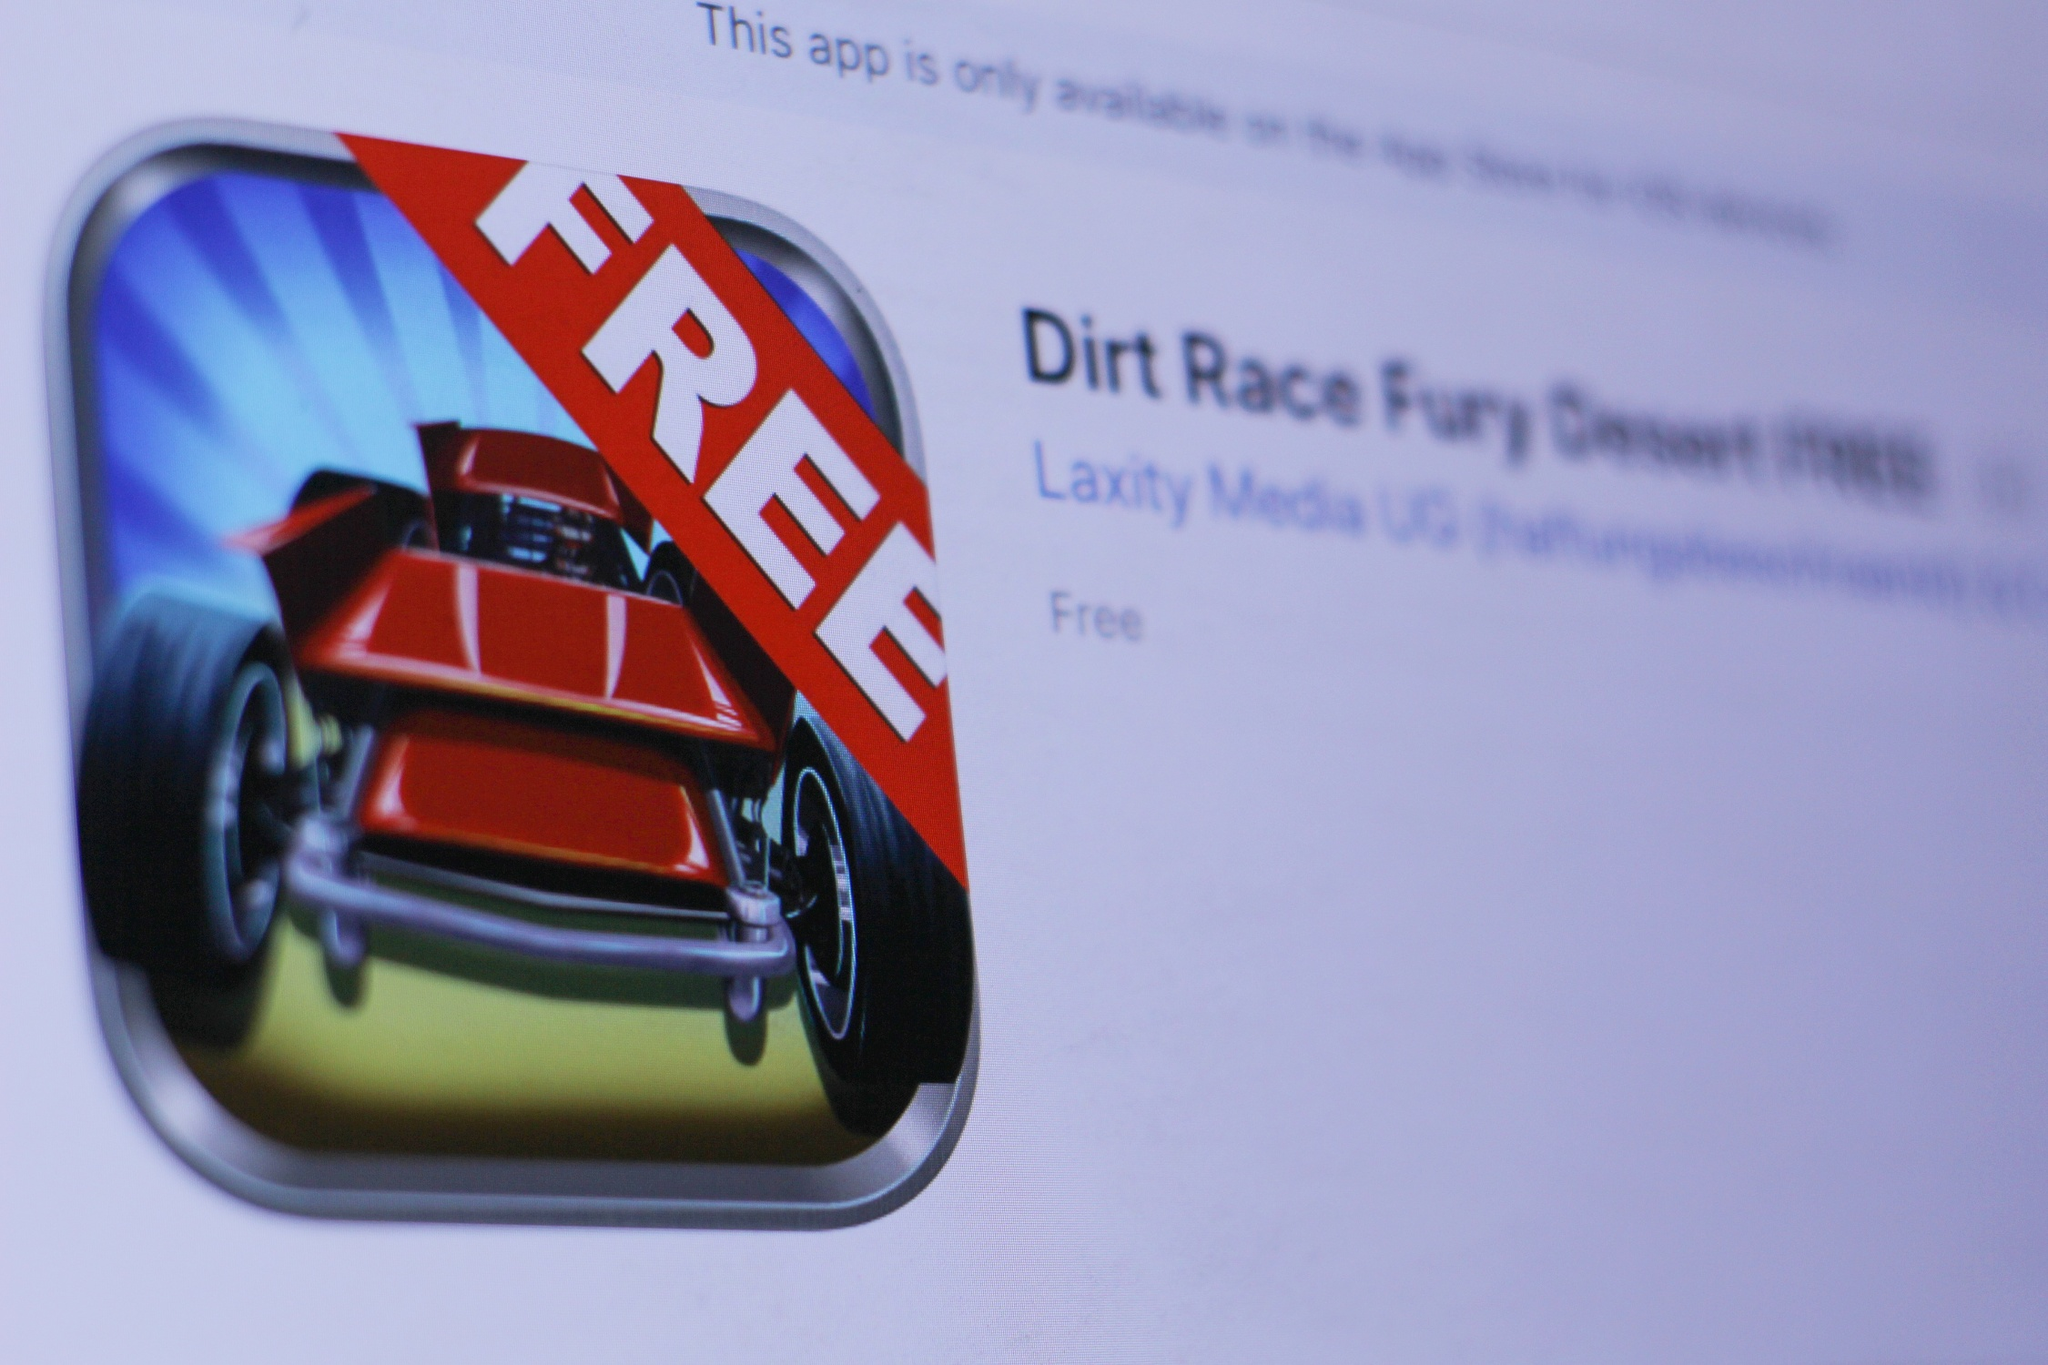What does the 'FREE' label on the app's icon imply about the app's monetization strategy? The 'FREE' label on the app's icon indicates that the application 'Dirt Race Fury Desert FREE' is available for download without any initial cost. This suggests that the developer, Laxity Media UG, likely adopts a freemium monetization strategy. Users can download and play the base game for free, but they might encounter in-app purchases or advertisements. These could include buying virtual currency, unlocking additional maps, vehicles, or premium features, and possibly ad removals to enhance the gaming experience. This strategy widens the potential user base by lowering the entry barrier while still providing opportunities to generate revenue. What technological considerations might be involved in keeping an app like this running smoothly? Maintaining an app like 'Dirt Race Fury Desert FREE' requires various technological considerations to ensure smooth operation and user satisfaction. Firstly, robust backend support is essential for handling user data, leaderboards, and in-app purchases. The app should have an efficient and responsive UI/UX design to provide seamless navigation and gameplay experience. Regular updates to the app will manage bugs, compatibility with new iOS versions, and introduce new features to keep the game engaging.

On the game development side, optimizing the graphics and performance for different iOS devices ensures that the app runs smoothly across a wide range of hardware specifications. The developers must also consider network stability, especially if the game includes any online multiplayer components or live events. Data encryption and secure communication channels are critical for protecting user data, particularly in transactions and personal information. Finally, an analytics framework to monitor user behavior and feedback can guide future improvements and help in making informed enhancements to the app’s functionality and content. Let’s say the app has a hidden treasure feature. How would players find it? In 'Dirt Race Fury Desert FREE', the hidden treasure feature could be an exciting addition that adds depth to the gameplay. Imagine players racing through visually stunning desert tracks, all while keeping an eye out for subtle clues and secret pathways that lead to special hidden treasures. These treasures might include rare car parts, exclusive skins, extra in-game currency, or even hidden levels that offer unique racing experiences.

To find these treasures, players would need to explore beyond the obvious tracks, perhaps venturing into less-trodden areas of the desert. They might encounter cryptic symbols or messages on ancient ruins scattered along the racing path, prompting them to decode these hints to unravel the treasure's location. The app could encourage players to participate in special time-limited events where the likelihood of encountering clues and treasures is higher. This feature not only enhances the sense of adventure but also promotes exploration and rewards curiosity, making the racing experience even more immersive and engaging. Imagine the app becomes a groundbreaking AR (augmented reality) game. What features would it have? If 'Dirt Race Fury Desert FREE' evolved into a groundbreaking AR game, it would revolutionize the gameplay experience by merging digital animations with the real world. Players would use their mobile devices to see virtual race tracks superimposed onto their surroundings, transforming everyday environments into thrilling racecourses. Here are some standout features it could have:

1. **Real-world Tracks:** Players could race through familiar locations like their neighborhood, parks, or city streets, converted into high-octane tracks filled with twists, turns, and jumps.

2. **Interactive Obstacles and Power-ups:** Virtual elements such as ramps, hoops, and barriers appear in the real world, requiring players to physically navigate around them, enhancing the sense of immersion.

3. **Multiplayer Mode:** Friends can join in, racing against each other in real-time, with their devices displaying their competitors’ cars as if they were actually present.

4. **Treasure Hunts:** Like hidden treasures, special AR hotspots can appear in various locations, urging players to explore and reach these points to unlock rewards and bonuses.

5. **Dynamic Weather and Terrain Effects:** Weather effects like rain, dust storms, and fog could dynamically affect the racing experience, making each race unique and challenging.

6. **Customizable AR Cars:** Players could customize their cars with AR skins that appear hyper-realistic, allowing for personalization that reflects their style on the real-world racetracks.

7. **Augmented Challenges and Events:** Special events with new challenges, such as racing a virtual character or battling an AR boss car, would keep players coming back for more.

8. **Fitness Integration:** Encourage physical activity by incorporating features that count physical steps taken in real life to earn in-game rewards, promoting health and engagement.

This AR integration would provide a compelling blend of physical movement and engaging gameplay, making each race not just a game but an adventure in the player’s own surroundings. 